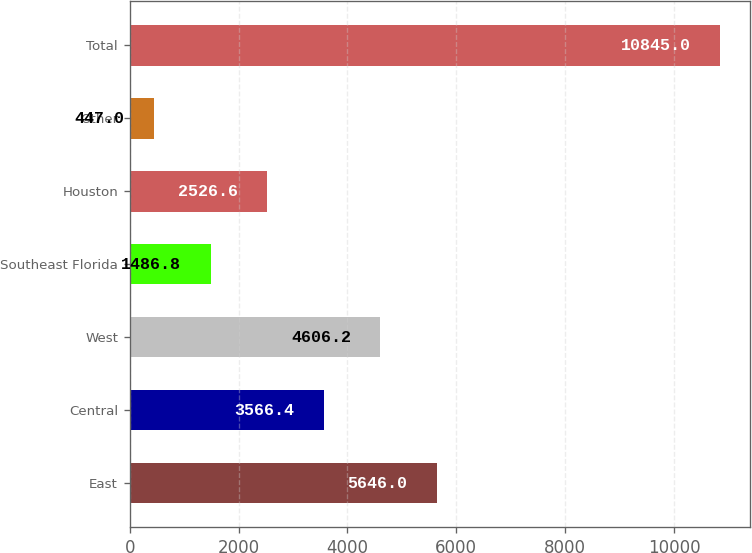<chart> <loc_0><loc_0><loc_500><loc_500><bar_chart><fcel>East<fcel>Central<fcel>West<fcel>Southeast Florida<fcel>Houston<fcel>Other<fcel>Total<nl><fcel>5646<fcel>3566.4<fcel>4606.2<fcel>1486.8<fcel>2526.6<fcel>447<fcel>10845<nl></chart> 